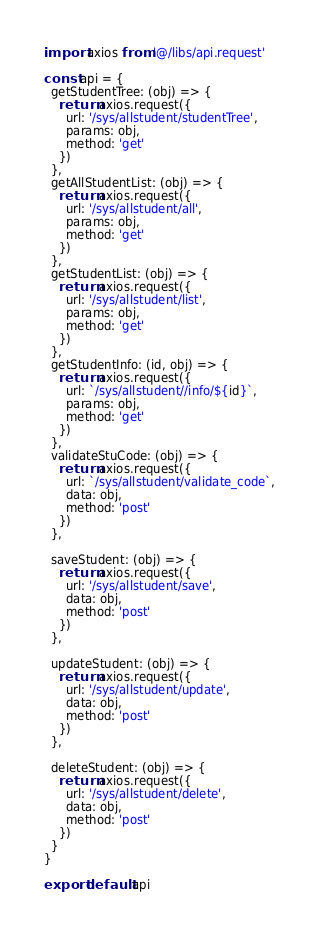Convert code to text. <code><loc_0><loc_0><loc_500><loc_500><_JavaScript_>import axios from '@/libs/api.request'

const api = {
  getStudentTree: (obj) => {
    return axios.request({
      url: '/sys/allstudent/studentTree',
      params: obj,
      method: 'get'
    })
  },
  getAllStudentList: (obj) => {
    return axios.request({
      url: '/sys/allstudent/all',
      params: obj,
      method: 'get'
    })
  },
  getStudentList: (obj) => {
    return axios.request({
      url: '/sys/allstudent/list',
      params: obj,
      method: 'get'
    })
  },
  getStudentInfo: (id, obj) => {
    return axios.request({
      url: `/sys/allstudent//info/${id}`,
      params: obj,
      method: 'get'
    })
  },
  validateStuCode: (obj) => {
    return axios.request({
      url: `/sys/allstudent/validate_code`,
      data: obj,
      method: 'post'
    })
  },

  saveStudent: (obj) => {
    return axios.request({
      url: '/sys/allstudent/save',
      data: obj,
      method: 'post'
    })
  },

  updateStudent: (obj) => {
    return axios.request({
      url: '/sys/allstudent/update',
      data: obj,
      method: 'post'
    })
  },

  deleteStudent: (obj) => {
    return axios.request({
      url: '/sys/allstudent/delete',
      data: obj,
      method: 'post'
    })
  }
}

export default api
</code> 